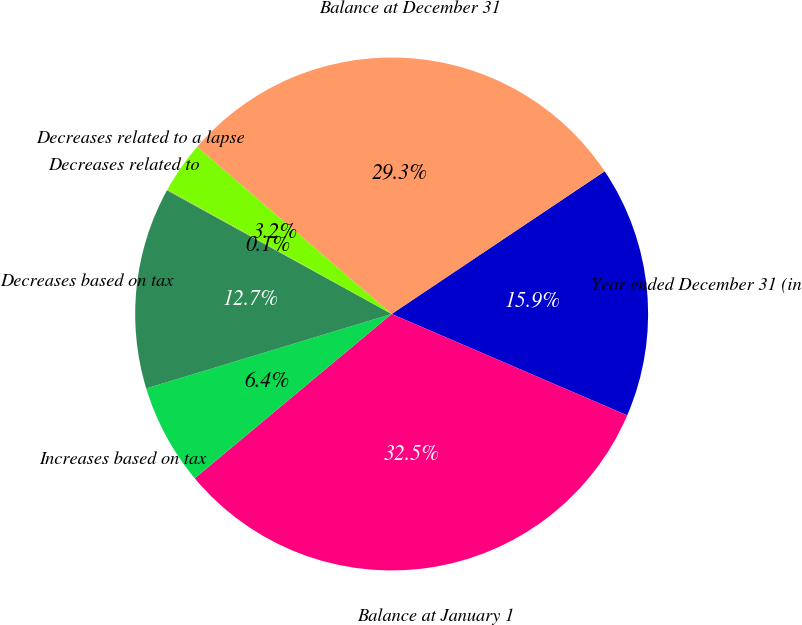<chart> <loc_0><loc_0><loc_500><loc_500><pie_chart><fcel>Year ended December 31 (in<fcel>Balance at January 1<fcel>Increases based on tax<fcel>Decreases based on tax<fcel>Decreases related to<fcel>Decreases related to a lapse<fcel>Balance at December 31<nl><fcel>15.86%<fcel>32.46%<fcel>6.38%<fcel>12.7%<fcel>0.07%<fcel>3.22%<fcel>29.3%<nl></chart> 